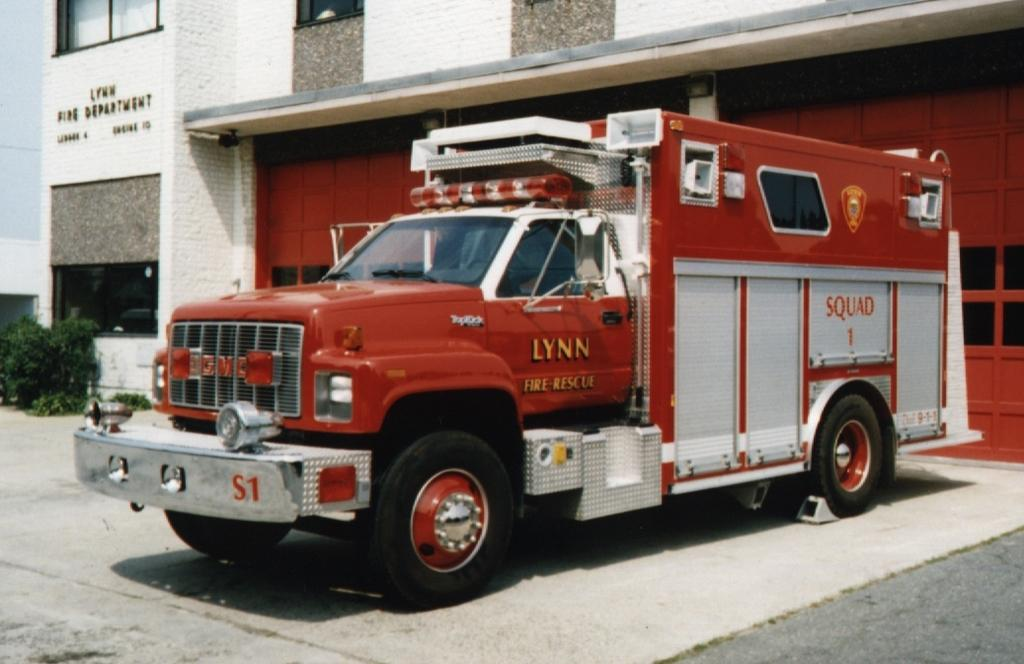What is the main subject of the image? There is a vehicle on a path in the image. What can be seen behind the vehicle? There is a building behind the vehicle. What is on the building? There is a name board on the building. What is in front of the building? There is a plant in front of the building. What type of mask is being worn by the plant in the image? There is no mask present in the image, as the plant is not a person or wearing any type of mask. 